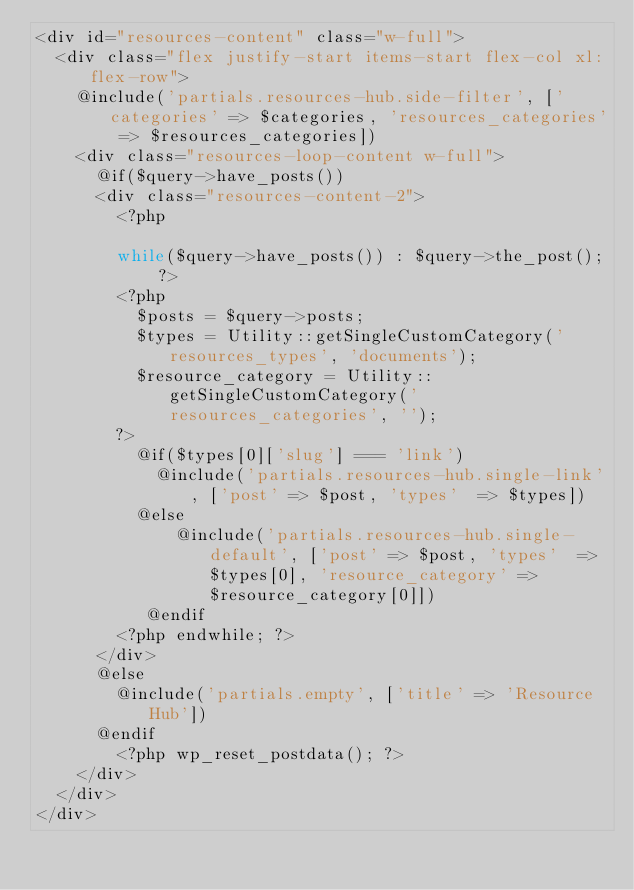<code> <loc_0><loc_0><loc_500><loc_500><_PHP_><div id="resources-content" class="w-full">
  <div class="flex justify-start items-start flex-col xl:flex-row">
    @include('partials.resources-hub.side-filter', ['categories' => $categories, 'resources_categories' => $resources_categories])
    <div class="resources-loop-content w-full">
      @if($query->have_posts())
      <div class="resources-content-2">
        <?php

        while($query->have_posts()) : $query->the_post(); ?>
        <?php
          $posts = $query->posts;
          $types = Utility::getSingleCustomCategory('resources_types', 'documents');
          $resource_category = Utility::getSingleCustomCategory('resources_categories', '');
        ?>
          @if($types[0]['slug'] === 'link')
            @include('partials.resources-hub.single-link', ['post' => $post, 'types'  => $types])
          @else
              @include('partials.resources-hub.single-default', ['post' => $post, 'types'  => $types[0], 'resource_category' => $resource_category[0]])
           @endif
        <?php endwhile; ?>
      </div>
      @else
        @include('partials.empty', ['title' => 'Resource Hub'])
      @endif
        <?php wp_reset_postdata(); ?>
    </div>
  </div>
</div>
</code> 